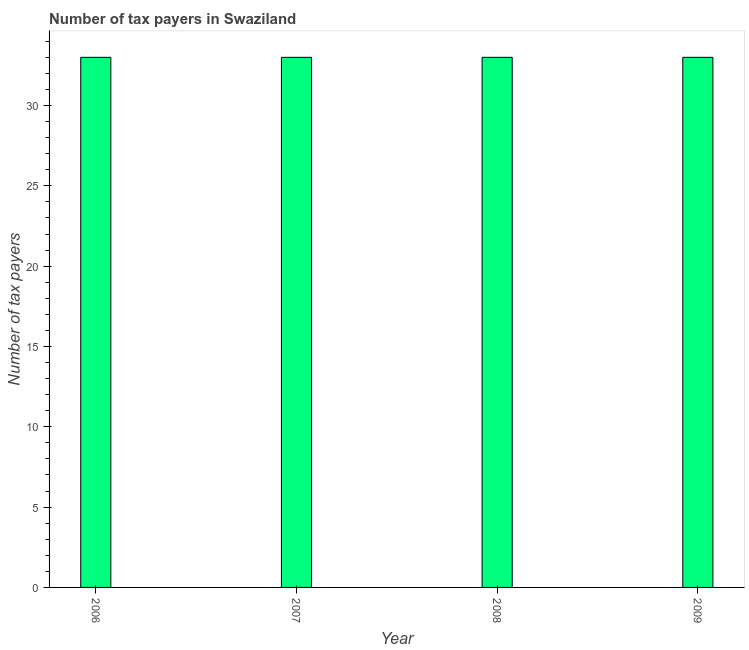Does the graph contain any zero values?
Provide a succinct answer. No. Does the graph contain grids?
Ensure brevity in your answer.  No. What is the title of the graph?
Your answer should be compact. Number of tax payers in Swaziland. What is the label or title of the X-axis?
Provide a short and direct response. Year. What is the label or title of the Y-axis?
Provide a short and direct response. Number of tax payers. Across all years, what is the minimum number of tax payers?
Your answer should be compact. 33. In which year was the number of tax payers minimum?
Ensure brevity in your answer.  2006. What is the sum of the number of tax payers?
Make the answer very short. 132. What is the median number of tax payers?
Make the answer very short. 33. What is the ratio of the number of tax payers in 2007 to that in 2008?
Offer a very short reply. 1. Is the number of tax payers in 2007 less than that in 2009?
Ensure brevity in your answer.  No. Is the difference between the number of tax payers in 2006 and 2008 greater than the difference between any two years?
Your answer should be very brief. Yes. Is the sum of the number of tax payers in 2006 and 2009 greater than the maximum number of tax payers across all years?
Give a very brief answer. Yes. How many bars are there?
Your answer should be compact. 4. What is the difference between two consecutive major ticks on the Y-axis?
Offer a very short reply. 5. What is the Number of tax payers in 2006?
Your response must be concise. 33. What is the Number of tax payers in 2009?
Keep it short and to the point. 33. What is the difference between the Number of tax payers in 2006 and 2009?
Offer a terse response. 0. What is the difference between the Number of tax payers in 2007 and 2008?
Your response must be concise. 0. What is the ratio of the Number of tax payers in 2006 to that in 2007?
Offer a terse response. 1. What is the ratio of the Number of tax payers in 2006 to that in 2008?
Offer a very short reply. 1. What is the ratio of the Number of tax payers in 2006 to that in 2009?
Make the answer very short. 1. What is the ratio of the Number of tax payers in 2007 to that in 2008?
Your answer should be very brief. 1. What is the ratio of the Number of tax payers in 2007 to that in 2009?
Provide a succinct answer. 1. What is the ratio of the Number of tax payers in 2008 to that in 2009?
Your answer should be very brief. 1. 